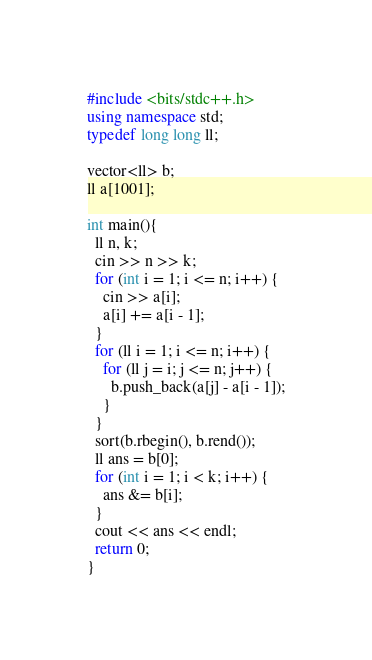Convert code to text. <code><loc_0><loc_0><loc_500><loc_500><_C++_>#include <bits/stdc++.h>
using namespace std;
typedef long long ll;

vector<ll> b;
ll a[1001];

int main(){
  ll n, k;
  cin >> n >> k;
  for (int i = 1; i <= n; i++) {
    cin >> a[i];
    a[i] += a[i - 1];
  }
  for (ll i = 1; i <= n; i++) {
    for (ll j = i; j <= n; j++) {
      b.push_back(a[j] - a[i - 1]);
    }
  }
  sort(b.rbegin(), b.rend());
  ll ans = b[0];
  for (int i = 1; i < k; i++) {
    ans &= b[i];
  }
  cout << ans << endl;
  return 0;
}
</code> 